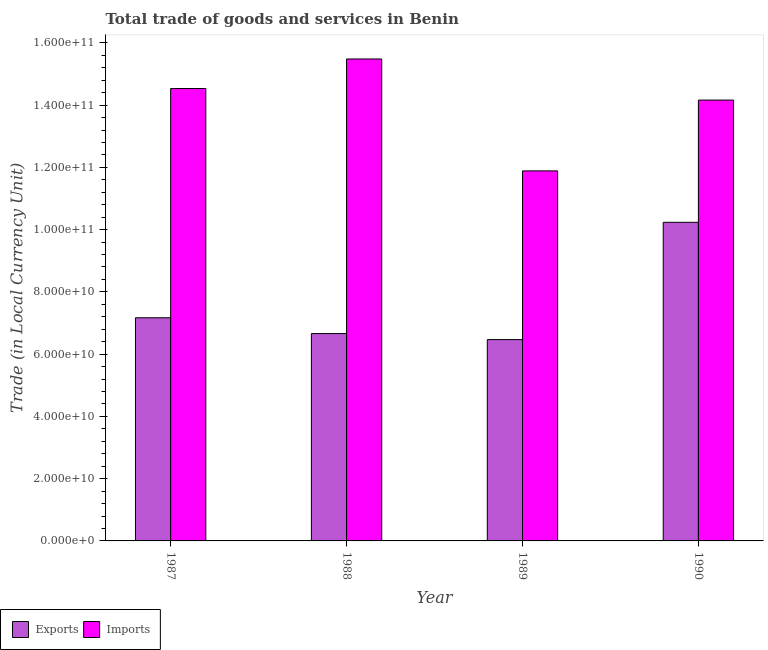Are the number of bars on each tick of the X-axis equal?
Offer a terse response. Yes. How many bars are there on the 1st tick from the left?
Keep it short and to the point. 2. How many bars are there on the 4th tick from the right?
Keep it short and to the point. 2. What is the imports of goods and services in 1987?
Your answer should be compact. 1.45e+11. Across all years, what is the maximum imports of goods and services?
Offer a terse response. 1.55e+11. Across all years, what is the minimum export of goods and services?
Your response must be concise. 6.47e+1. In which year was the imports of goods and services minimum?
Your answer should be very brief. 1989. What is the total export of goods and services in the graph?
Provide a succinct answer. 3.05e+11. What is the difference between the export of goods and services in 1987 and that in 1989?
Make the answer very short. 7.01e+09. What is the difference between the export of goods and services in 1988 and the imports of goods and services in 1990?
Your answer should be very brief. -3.57e+1. What is the average export of goods and services per year?
Keep it short and to the point. 7.63e+1. In how many years, is the export of goods and services greater than 152000000000 LCU?
Offer a very short reply. 0. What is the ratio of the export of goods and services in 1989 to that in 1990?
Your response must be concise. 0.63. What is the difference between the highest and the second highest imports of goods and services?
Make the answer very short. 9.50e+09. What is the difference between the highest and the lowest export of goods and services?
Offer a terse response. 3.77e+1. Is the sum of the imports of goods and services in 1988 and 1989 greater than the maximum export of goods and services across all years?
Keep it short and to the point. Yes. What does the 2nd bar from the left in 1988 represents?
Your response must be concise. Imports. What does the 2nd bar from the right in 1990 represents?
Provide a succinct answer. Exports. Are all the bars in the graph horizontal?
Your answer should be compact. No. How many years are there in the graph?
Offer a terse response. 4. How many legend labels are there?
Your response must be concise. 2. What is the title of the graph?
Provide a short and direct response. Total trade of goods and services in Benin. What is the label or title of the Y-axis?
Ensure brevity in your answer.  Trade (in Local Currency Unit). What is the Trade (in Local Currency Unit) of Exports in 1987?
Keep it short and to the point. 7.17e+1. What is the Trade (in Local Currency Unit) in Imports in 1987?
Give a very brief answer. 1.45e+11. What is the Trade (in Local Currency Unit) of Exports in 1988?
Your answer should be very brief. 6.66e+1. What is the Trade (in Local Currency Unit) in Imports in 1988?
Your answer should be compact. 1.55e+11. What is the Trade (in Local Currency Unit) of Exports in 1989?
Your answer should be very brief. 6.47e+1. What is the Trade (in Local Currency Unit) of Imports in 1989?
Make the answer very short. 1.19e+11. What is the Trade (in Local Currency Unit) of Exports in 1990?
Provide a succinct answer. 1.02e+11. What is the Trade (in Local Currency Unit) of Imports in 1990?
Keep it short and to the point. 1.42e+11. Across all years, what is the maximum Trade (in Local Currency Unit) in Exports?
Your answer should be very brief. 1.02e+11. Across all years, what is the maximum Trade (in Local Currency Unit) in Imports?
Provide a succinct answer. 1.55e+11. Across all years, what is the minimum Trade (in Local Currency Unit) in Exports?
Your response must be concise. 6.47e+1. Across all years, what is the minimum Trade (in Local Currency Unit) in Imports?
Give a very brief answer. 1.19e+11. What is the total Trade (in Local Currency Unit) in Exports in the graph?
Your response must be concise. 3.05e+11. What is the total Trade (in Local Currency Unit) of Imports in the graph?
Ensure brevity in your answer.  5.61e+11. What is the difference between the Trade (in Local Currency Unit) of Exports in 1987 and that in 1988?
Your answer should be compact. 5.08e+09. What is the difference between the Trade (in Local Currency Unit) of Imports in 1987 and that in 1988?
Your response must be concise. -9.50e+09. What is the difference between the Trade (in Local Currency Unit) of Exports in 1987 and that in 1989?
Offer a very short reply. 7.01e+09. What is the difference between the Trade (in Local Currency Unit) in Imports in 1987 and that in 1989?
Make the answer very short. 2.65e+1. What is the difference between the Trade (in Local Currency Unit) in Exports in 1987 and that in 1990?
Provide a succinct answer. -3.07e+1. What is the difference between the Trade (in Local Currency Unit) of Imports in 1987 and that in 1990?
Ensure brevity in your answer.  3.71e+09. What is the difference between the Trade (in Local Currency Unit) in Exports in 1988 and that in 1989?
Your answer should be compact. 1.94e+09. What is the difference between the Trade (in Local Currency Unit) of Imports in 1988 and that in 1989?
Provide a succinct answer. 3.60e+1. What is the difference between the Trade (in Local Currency Unit) in Exports in 1988 and that in 1990?
Keep it short and to the point. -3.57e+1. What is the difference between the Trade (in Local Currency Unit) in Imports in 1988 and that in 1990?
Offer a very short reply. 1.32e+1. What is the difference between the Trade (in Local Currency Unit) in Exports in 1989 and that in 1990?
Ensure brevity in your answer.  -3.77e+1. What is the difference between the Trade (in Local Currency Unit) in Imports in 1989 and that in 1990?
Provide a succinct answer. -2.27e+1. What is the difference between the Trade (in Local Currency Unit) of Exports in 1987 and the Trade (in Local Currency Unit) of Imports in 1988?
Your response must be concise. -8.31e+1. What is the difference between the Trade (in Local Currency Unit) in Exports in 1987 and the Trade (in Local Currency Unit) in Imports in 1989?
Ensure brevity in your answer.  -4.72e+1. What is the difference between the Trade (in Local Currency Unit) of Exports in 1987 and the Trade (in Local Currency Unit) of Imports in 1990?
Ensure brevity in your answer.  -6.99e+1. What is the difference between the Trade (in Local Currency Unit) of Exports in 1988 and the Trade (in Local Currency Unit) of Imports in 1989?
Make the answer very short. -5.23e+1. What is the difference between the Trade (in Local Currency Unit) of Exports in 1988 and the Trade (in Local Currency Unit) of Imports in 1990?
Provide a short and direct response. -7.50e+1. What is the difference between the Trade (in Local Currency Unit) in Exports in 1989 and the Trade (in Local Currency Unit) in Imports in 1990?
Your response must be concise. -7.69e+1. What is the average Trade (in Local Currency Unit) in Exports per year?
Ensure brevity in your answer.  7.63e+1. What is the average Trade (in Local Currency Unit) of Imports per year?
Your answer should be compact. 1.40e+11. In the year 1987, what is the difference between the Trade (in Local Currency Unit) in Exports and Trade (in Local Currency Unit) in Imports?
Ensure brevity in your answer.  -7.36e+1. In the year 1988, what is the difference between the Trade (in Local Currency Unit) in Exports and Trade (in Local Currency Unit) in Imports?
Make the answer very short. -8.82e+1. In the year 1989, what is the difference between the Trade (in Local Currency Unit) in Exports and Trade (in Local Currency Unit) in Imports?
Give a very brief answer. -5.42e+1. In the year 1990, what is the difference between the Trade (in Local Currency Unit) of Exports and Trade (in Local Currency Unit) of Imports?
Provide a short and direct response. -3.93e+1. What is the ratio of the Trade (in Local Currency Unit) in Exports in 1987 to that in 1988?
Give a very brief answer. 1.08. What is the ratio of the Trade (in Local Currency Unit) in Imports in 1987 to that in 1988?
Your response must be concise. 0.94. What is the ratio of the Trade (in Local Currency Unit) in Exports in 1987 to that in 1989?
Offer a very short reply. 1.11. What is the ratio of the Trade (in Local Currency Unit) in Imports in 1987 to that in 1989?
Your answer should be very brief. 1.22. What is the ratio of the Trade (in Local Currency Unit) of Exports in 1987 to that in 1990?
Make the answer very short. 0.7. What is the ratio of the Trade (in Local Currency Unit) in Imports in 1987 to that in 1990?
Provide a short and direct response. 1.03. What is the ratio of the Trade (in Local Currency Unit) of Exports in 1988 to that in 1989?
Make the answer very short. 1.03. What is the ratio of the Trade (in Local Currency Unit) in Imports in 1988 to that in 1989?
Make the answer very short. 1.3. What is the ratio of the Trade (in Local Currency Unit) in Exports in 1988 to that in 1990?
Your answer should be very brief. 0.65. What is the ratio of the Trade (in Local Currency Unit) of Imports in 1988 to that in 1990?
Offer a very short reply. 1.09. What is the ratio of the Trade (in Local Currency Unit) of Exports in 1989 to that in 1990?
Offer a terse response. 0.63. What is the ratio of the Trade (in Local Currency Unit) in Imports in 1989 to that in 1990?
Give a very brief answer. 0.84. What is the difference between the highest and the second highest Trade (in Local Currency Unit) of Exports?
Ensure brevity in your answer.  3.07e+1. What is the difference between the highest and the second highest Trade (in Local Currency Unit) of Imports?
Ensure brevity in your answer.  9.50e+09. What is the difference between the highest and the lowest Trade (in Local Currency Unit) in Exports?
Offer a very short reply. 3.77e+1. What is the difference between the highest and the lowest Trade (in Local Currency Unit) of Imports?
Offer a terse response. 3.60e+1. 